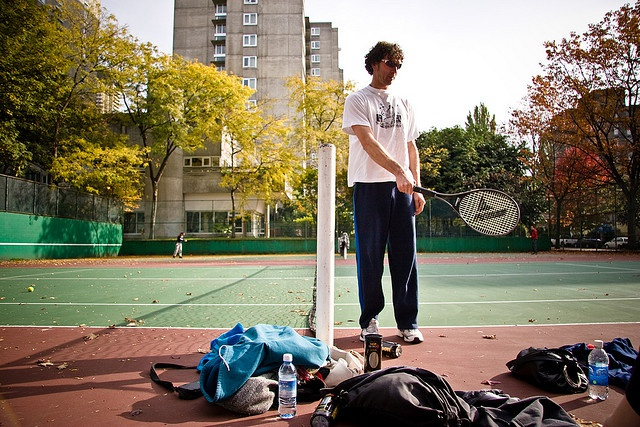Describe the objects in this image and their specific colors. I can see people in black, lightgray, pink, and darkgray tones, backpack in black, brown, blue, and navy tones, backpack in black, darkgray, gray, and lightgray tones, handbag in black, salmon, darkgray, and gray tones, and tennis racket in black, gray, beige, and darkgray tones in this image. 